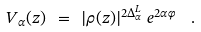<formula> <loc_0><loc_0><loc_500><loc_500>V _ { \alpha } ( z ) \ = \ | \rho ( z ) | ^ { 2 \Delta ^ { L } _ { \alpha } } \, e ^ { 2 \alpha \varphi } \ \ .</formula> 